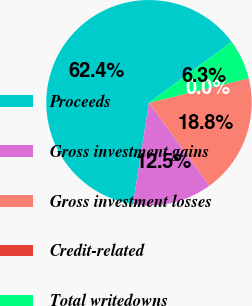<chart> <loc_0><loc_0><loc_500><loc_500><pie_chart><fcel>Proceeds<fcel>Gross investment gains<fcel>Gross investment losses<fcel>Credit-related<fcel>Total writedowns<nl><fcel>62.41%<fcel>12.52%<fcel>18.75%<fcel>0.04%<fcel>6.28%<nl></chart> 